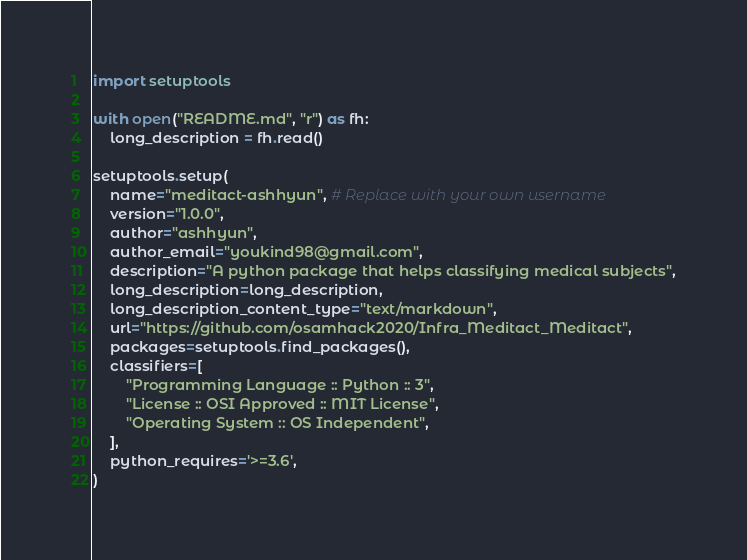Convert code to text. <code><loc_0><loc_0><loc_500><loc_500><_Python_>import setuptools

with open("README.md", "r") as fh:
    long_description = fh.read()

setuptools.setup(
    name="meditact-ashhyun", # Replace with your own username
    version="1.0.0",
    author="ashhyun",
    author_email="youkind98@gmail.com",
    description="A python package that helps classifying medical subjects",
    long_description=long_description,
    long_description_content_type="text/markdown",
    url="https://github.com/osamhack2020/Infra_Meditact_Meditact",
    packages=setuptools.find_packages(),
    classifiers=[
        "Programming Language :: Python :: 3",
        "License :: OSI Approved :: MIT License",
        "Operating System :: OS Independent",
    ],
    python_requires='>=3.6',
)</code> 